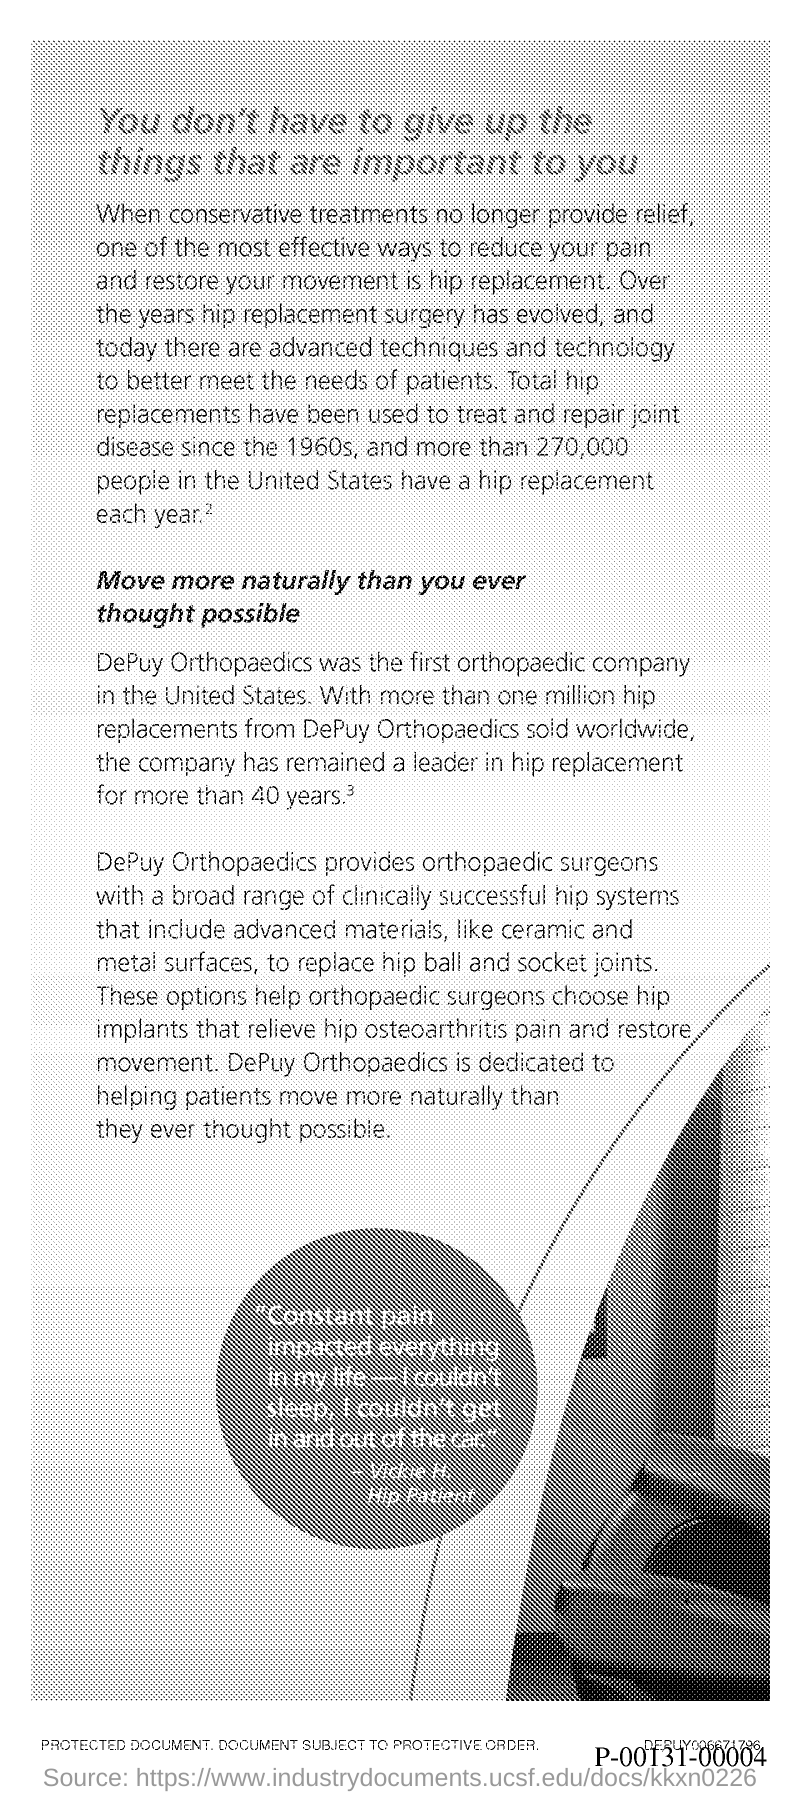Which was the first orthopaedic company in the United States?
Your answer should be compact. DEPUY ORTHOPAEDICS. 